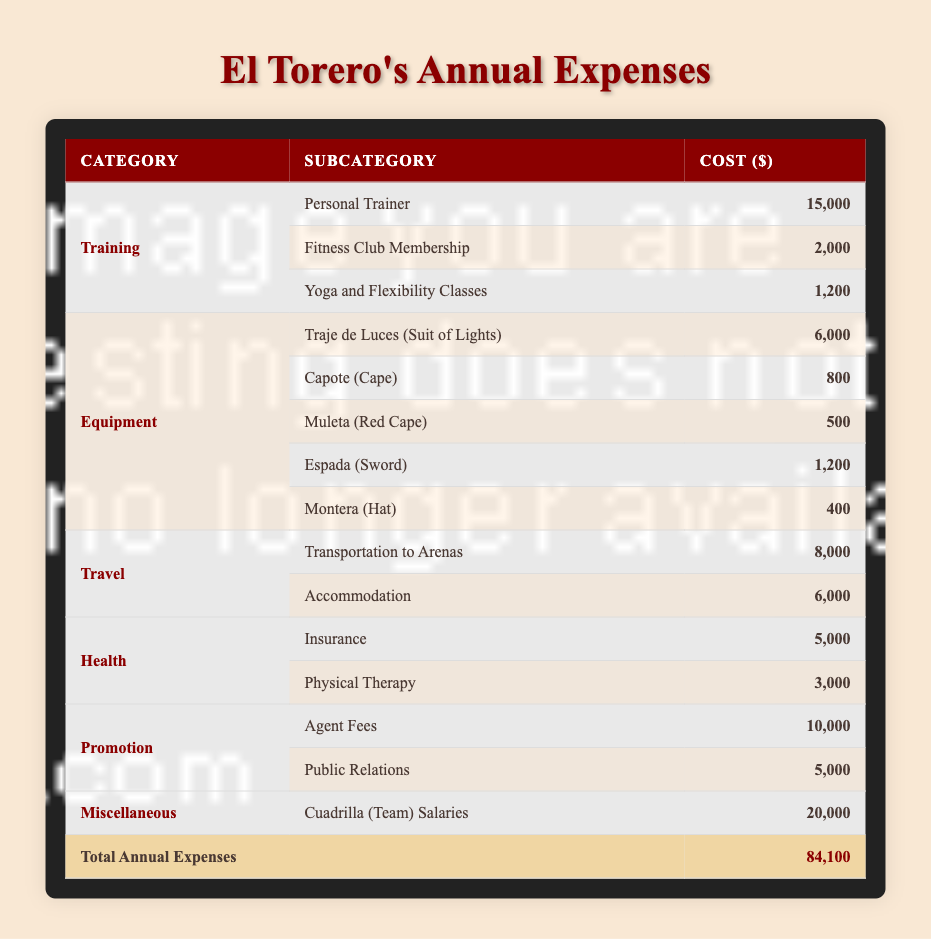What is the total cost of equipment for a bullfighter? To find the total cost of equipment, we add up all the costs listed under the Equipment category: 6000 (Traje de Luces) + 800 (Capote) + 500 (Muleta) + 1200 (Espada) + 400 (Montera). This gives us a total of 6000 + 800 + 500 + 1200 + 400 = 8900.
Answer: 8900 How much does a bullfighter spend on promotion expenses? To find the total promotion expenses, we sum the costs in the Promotion category: 10000 (Agent Fees) + 5000 (Public Relations). The sum is 10000 + 5000 = 15000.
Answer: 15000 Is the cost of personal trainer higher than the cost of insurance? The cost of the personal trainer is 15000, while the cost of insurance is 5000. Since 15000 is greater than 5000, the statement is true.
Answer: Yes What is the total cost of training, travel, and health expenses combined? We first find the individual totals: Training = 15000 + 2000 + 1200 = 18200, Travel = 8000 + 6000 = 14000, Health = 5000 + 3000 = 8000. Next, we add these totals together: 18200 + 14000 + 8000 = 40200.
Answer: 40200 What percentage of the total annual expenses is spent on the cuadrilla (team) salaries? The total annual expenses amount to 84100, while the cuadrilla salaries are 20000. To find the percentage, we calculate (20000 / 84100) * 100, which equals approximately 23.7%.
Answer: 23.7% How much more is spent on training compared to equipment? First, calculate the total training expenses: 15000 + 2000 + 1200 = 18200. As calculated earlier, the total equipment expenses are 8900. Subtract the equipment total from the training total: 18200 - 8900 = 9310. Therefore, 9310 more is spent on training compared to equipment.
Answer: 9310 Are the total travel expenses less than the total health expenses? The total travel expenses are 8000 (Transportation) + 6000 (Accommodation) = 14000. The total health expenses are 5000 (Insurance) + 3000 (Physical Therapy) = 8000. Since 14000 is greater than 8000, the statement is false.
Answer: No What is the most expensive single item expense listed in the table? By examining all the costs in the table, the highest value is 20000 for Cuadrilla (Team) Salaries, which is greater than any other expenditure listed.
Answer: Cuadrilla (Team) Salaries How much is spent on health if the cost of physical therapy is removed from the total? The health expenses total is 5000 (Insurance) + 3000 (Physical Therapy) = 8000. If we remove the cost of physical therapy, we are left with just the insurance cost of 5000.
Answer: 5000 